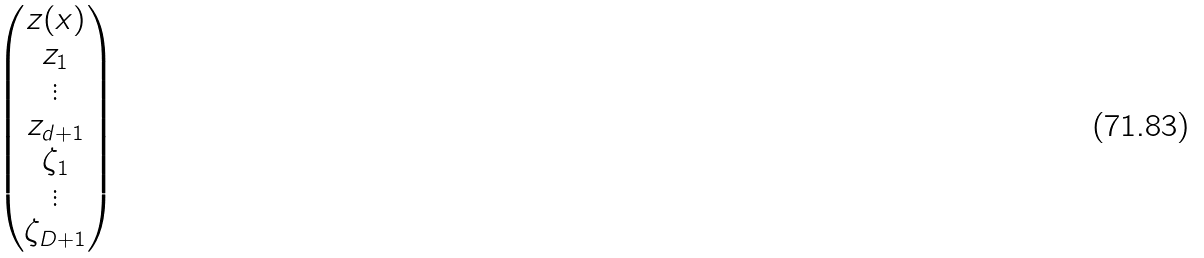Convert formula to latex. <formula><loc_0><loc_0><loc_500><loc_500>\begin{pmatrix} z ( x ) \\ z _ { 1 } \\ \vdots \\ z _ { d + 1 } \\ \zeta _ { 1 } \\ \vdots \\ \zeta _ { D + 1 } \end{pmatrix}</formula> 